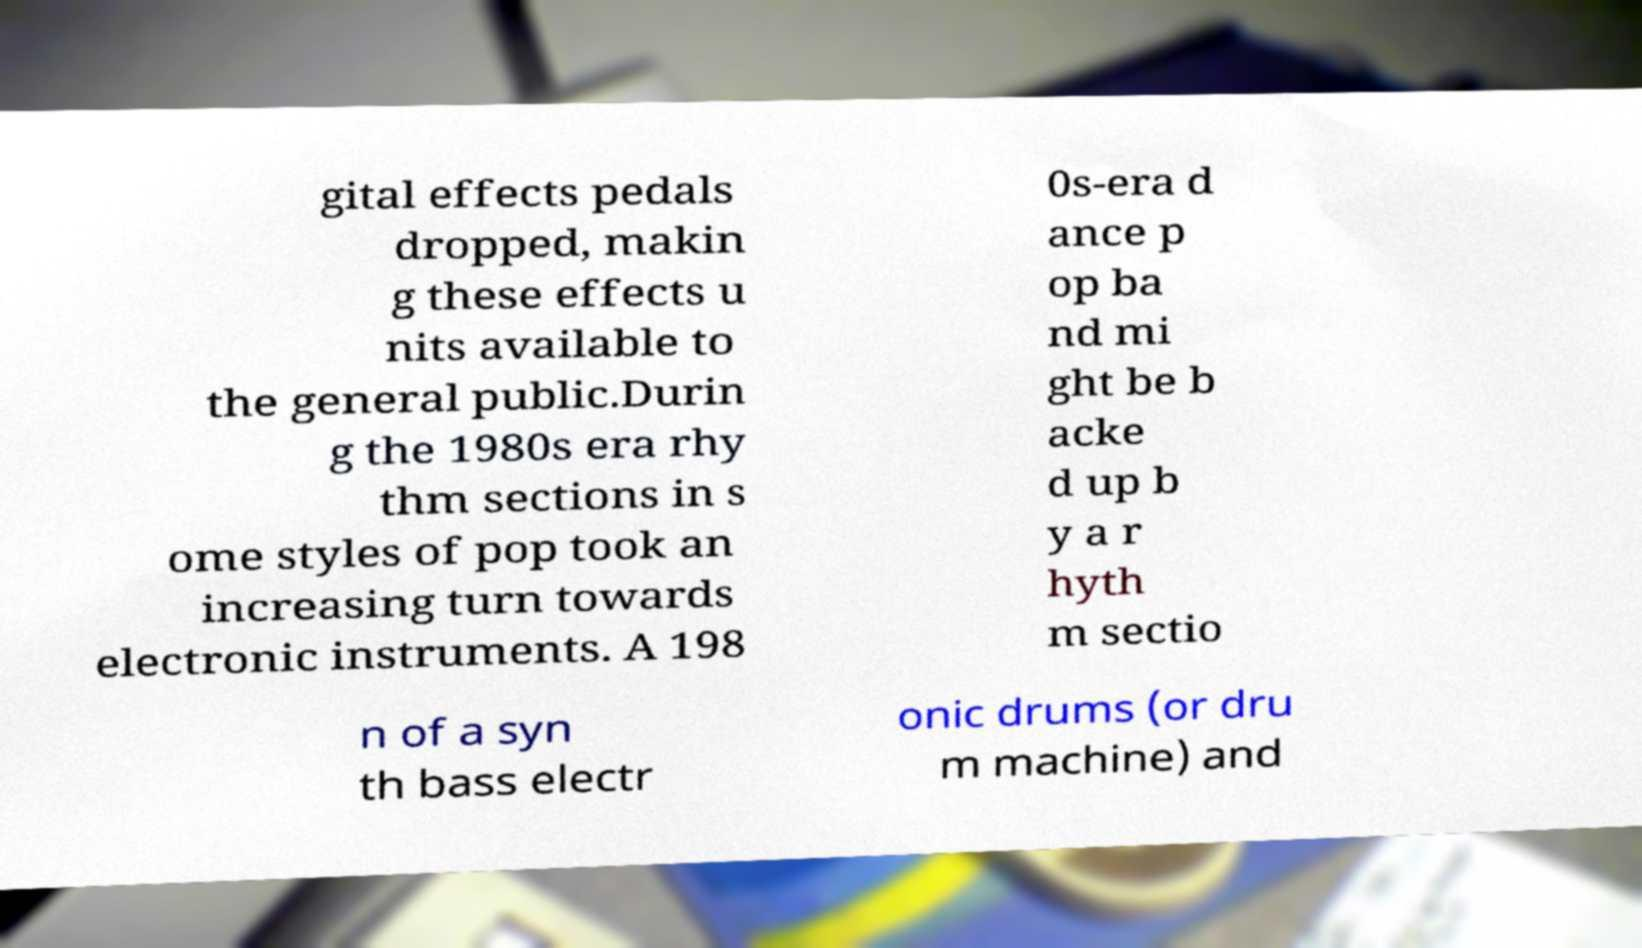Please read and relay the text visible in this image. What does it say? gital effects pedals dropped, makin g these effects u nits available to the general public.Durin g the 1980s era rhy thm sections in s ome styles of pop took an increasing turn towards electronic instruments. A 198 0s-era d ance p op ba nd mi ght be b acke d up b y a r hyth m sectio n of a syn th bass electr onic drums (or dru m machine) and 